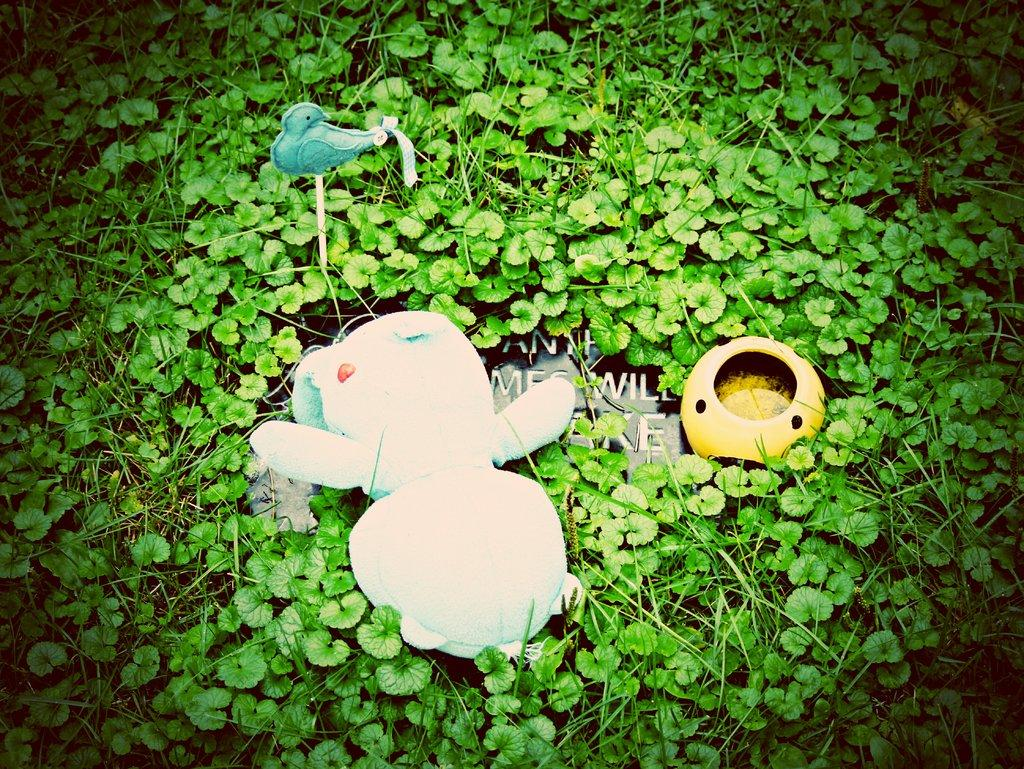How many toys can be seen in the image? There are two toys in the image. What is the board in the image used for? The board in the image has text on it and is placed on the ground. What type of vegetation is present in the image? There are plants in the image, and they are green in color. What type of company is represented by the toys in the image? There is no indication of a company in the image; it only features two toys, a board, plants, and text on the board. What day of the week is depicted in the image? The image does not depict a specific day of the week; it only shows the objects mentioned in the facts. 